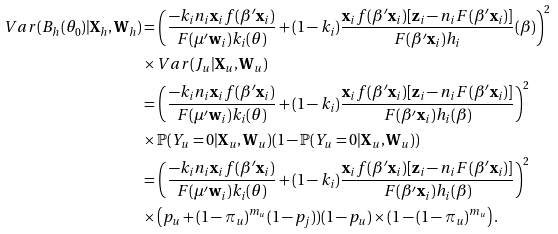<formula> <loc_0><loc_0><loc_500><loc_500>V a r ( B _ { h } ( \theta _ { 0 } ) | \mathbf X _ { h } , \mathbf W _ { h } ) & = \left ( \frac { - k _ { i } n _ { i } \mathbf x _ { i } f ( \beta ^ { \prime } \mathbf x _ { i } ) } { F ( \mu ^ { \prime } \mathbf w _ { i } ) k _ { i } ( \theta ) } + ( 1 - k _ { i } ) \frac { \mathbf x _ { i } f ( \beta ^ { \prime } \mathbf x _ { i } ) [ \mathbf z _ { i } - n _ { i } F ( \beta ^ { \prime } \mathbf x _ { i } ) ] } { F ( \beta ^ { \prime } \mathbf x _ { i } ) h _ { i } } ( \beta ) \right ) ^ { 2 } \\ & \times V a r ( J _ { u } | \mathbf X _ { u } , \mathbf W _ { u } ) \\ & = \left ( \frac { - k _ { i } n _ { i } \mathbf x _ { i } f ( \beta ^ { \prime } \mathbf x _ { i } ) } { F ( \mu ^ { \prime } \mathbf w _ { i } ) k _ { i } ( \theta ) } + ( 1 - k _ { i } ) \frac { \mathbf x _ { i } f ( \beta ^ { \prime } \mathbf x _ { i } ) [ \mathbf z _ { i } - n _ { i } F ( \beta ^ { \prime } \mathbf x _ { i } ) ] } { F ( \beta ^ { \prime } \mathbf x _ { i } ) h _ { i } ( \beta ) } \right ) ^ { 2 } \\ & \times \mathbb { P } ( Y _ { u } = 0 | \mathbf X _ { u } , \mathbf W _ { u } ) ( 1 - \mathbb { P } ( Y _ { u } = 0 | \mathbf X _ { u } , \mathbf W _ { u } ) ) \\ & = \left ( \frac { - k _ { i } n _ { i } \mathbf x _ { i } f ( \beta ^ { \prime } \mathbf x _ { i } ) } { F ( \mu ^ { \prime } \mathbf w _ { i } ) k _ { i } ( \theta ) } + ( 1 - k _ { i } ) \frac { \mathbf x _ { i } f ( \beta ^ { \prime } \mathbf x _ { i } ) [ \mathbf z _ { i } - n _ { i } F ( \beta ^ { \prime } \mathbf x _ { i } ) ] } { F ( \beta ^ { \prime } \mathbf x _ { i } ) h _ { i } ( \beta ) } \right ) ^ { 2 } \\ & \times \left ( p _ { u } + ( 1 - \pi _ { u } ) ^ { m _ { u } } ( 1 - p _ { j } ) ) ( 1 - p _ { u } ) \times ( 1 - ( 1 - \pi _ { u } ) ^ { m _ { u } } \right ) .</formula> 